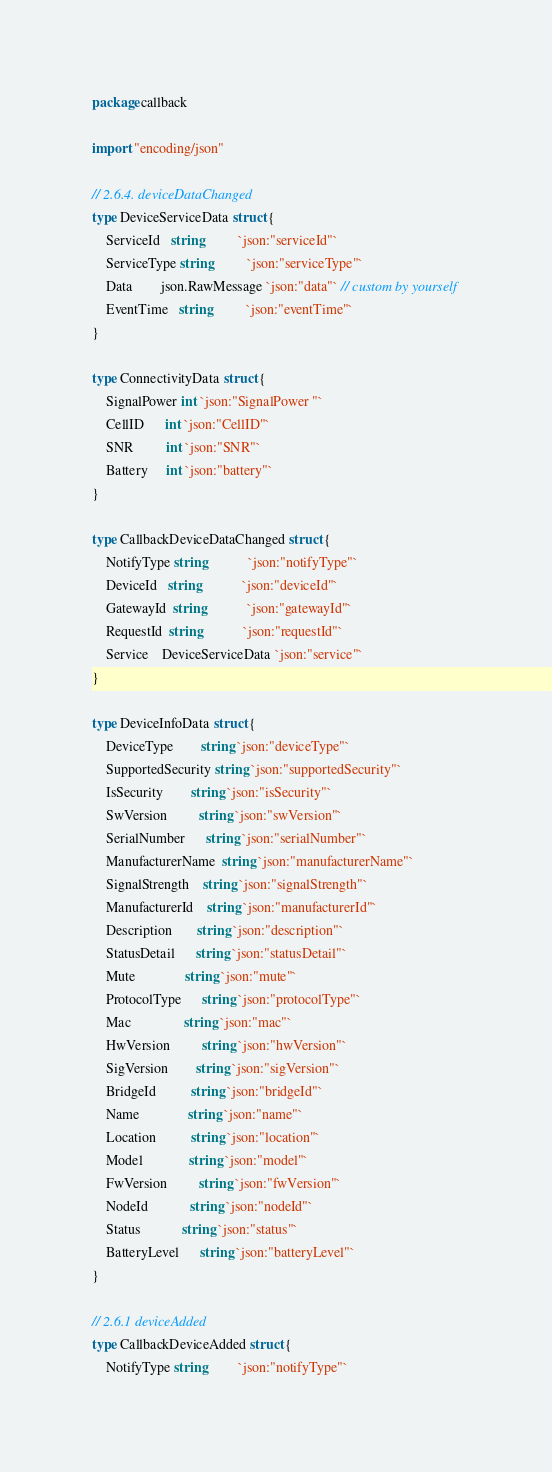<code> <loc_0><loc_0><loc_500><loc_500><_Go_>package callback

import "encoding/json"

// 2.6.4. deviceDataChanged
type DeviceServiceData struct {
	ServiceId   string          `json:"serviceId"`
	ServiceType string          `json:"serviceType"`
	Data        json.RawMessage `json:"data"` // custom by yourself
	EventTime   string          `json:"eventTime"`
}

type ConnectivityData struct {
	SignalPower int `json:"SignalPower "`
	CellID      int `json:"CellID"`
	SNR         int `json:"SNR"`
	Battery     int `json:"battery"`
}

type CallbackDeviceDataChanged struct {
	NotifyType string            `json:"notifyType"`
	DeviceId   string            `json:"deviceId"`
	GatewayId  string            `json:"gatewayId"`
	RequestId  string            `json:"requestId"`
	Service    DeviceServiceData `json:"service"`
}

type DeviceInfoData struct {
	DeviceType        string `json:"deviceType"`
	SupportedSecurity string `json:"supportedSecurity"`
	IsSecurity        string `json:"isSecurity"`
	SwVersion         string `json:"swVersion"`
	SerialNumber      string `json:"serialNumber"`
	ManufacturerName  string `json:"manufacturerName"`
	SignalStrength    string `json:"signalStrength"`
	ManufacturerId    string `json:"manufacturerId"`
	Description       string `json:"description"`
	StatusDetail      string `json:"statusDetail"`
	Mute              string `json:"mute"`
	ProtocolType      string `json:"protocolType"`
	Mac               string `json:"mac"`
	HwVersion         string `json:"hwVersion"`
	SigVersion        string `json:"sigVersion"`
	BridgeId          string `json:"bridgeId"`
	Name              string `json:"name"`
	Location          string `json:"location"`
	Model             string `json:"model"`
	FwVersion         string `json:"fwVersion"`
	NodeId            string `json:"nodeId"`
	Status            string `json:"status"`
	BatteryLevel      string `json:"batteryLevel"`
}

// 2.6.1 deviceAdded
type CallbackDeviceAdded struct {
	NotifyType string         `json:"notifyType"`</code> 